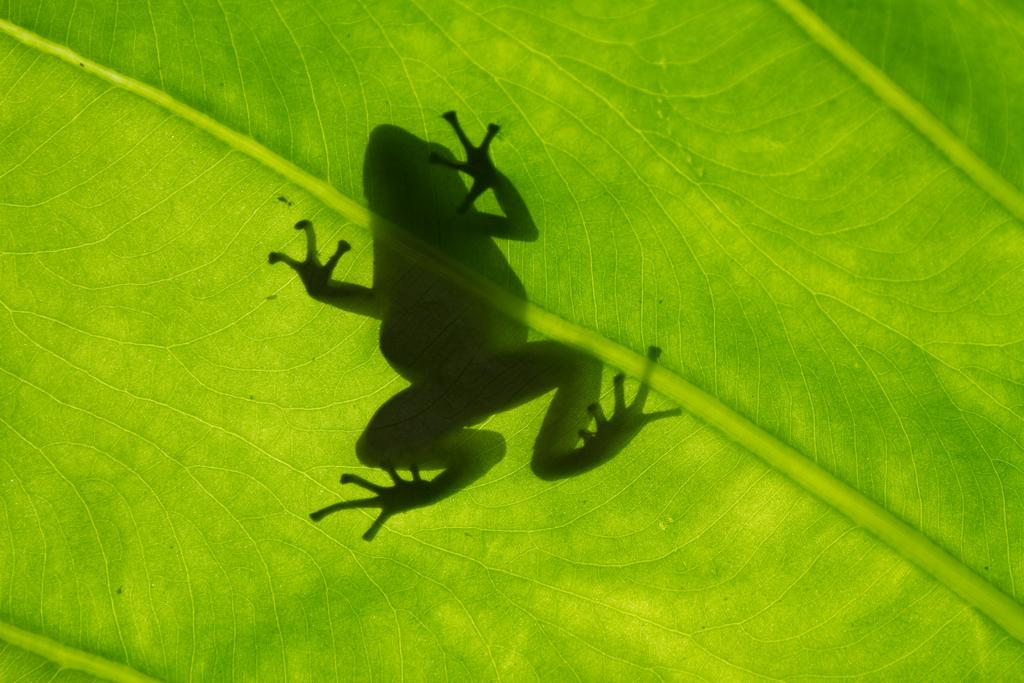What animal is present in the image? There is a frog in the image. Where is the frog located? The frog is on a green leaf. What type of blade is being used by the visitor in the image? There is no visitor or blade present in the image; it only features a frog on a green leaf. 